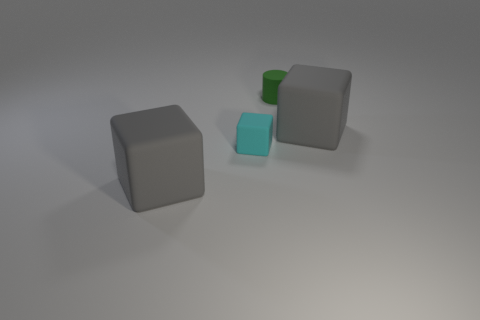How many cylinders are either green rubber objects or small cyan objects?
Ensure brevity in your answer.  1. Are there any rubber blocks left of the cyan thing?
Ensure brevity in your answer.  Yes. There is a cyan matte thing; is its shape the same as the gray matte object in front of the small cyan rubber block?
Provide a short and direct response. Yes. What number of objects are big gray things that are to the right of the green rubber object or small matte things?
Provide a short and direct response. 3. How many big gray rubber objects are on the left side of the green cylinder and behind the small block?
Give a very brief answer. 0. How many things are things that are to the right of the cyan object or matte things behind the small cyan cube?
Ensure brevity in your answer.  2. How many other objects are the same shape as the tiny cyan thing?
Provide a succinct answer. 2. What number of other objects are there of the same size as the cyan object?
Provide a short and direct response. 1. There is a big thing behind the big thing left of the small green cylinder; what color is it?
Your answer should be compact. Gray. What number of big cubes are in front of the tiny object that is left of the small rubber cylinder that is on the right side of the cyan matte thing?
Make the answer very short. 1. 